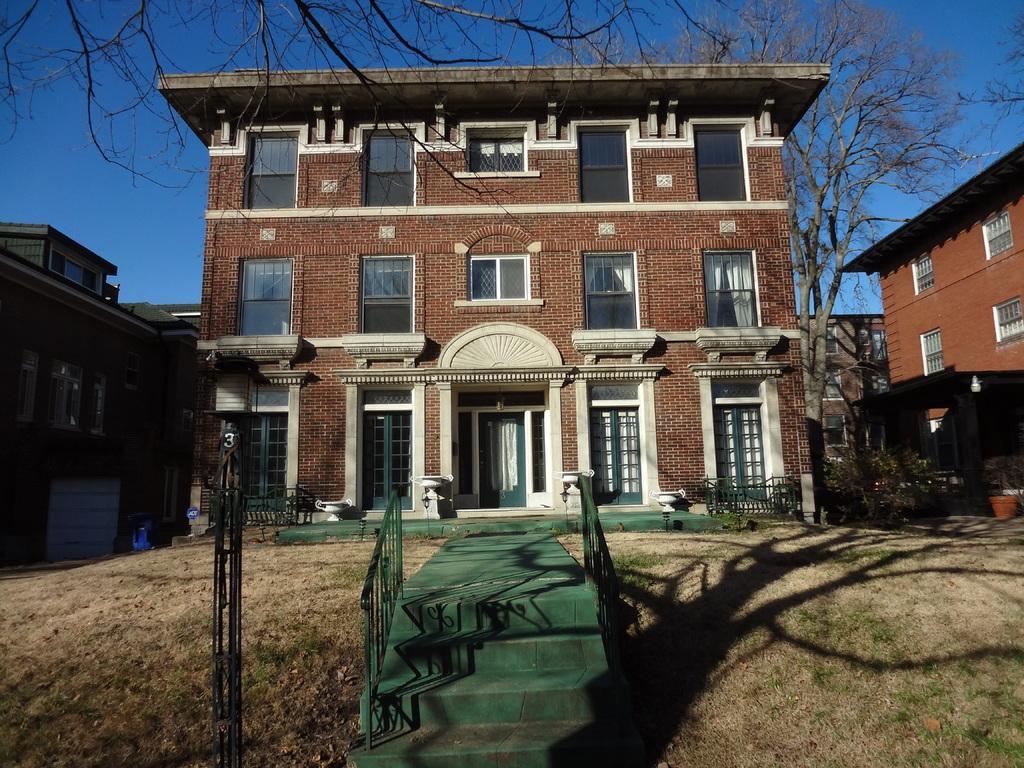Describe this image in one or two sentences. This image consists of the building. It has doors and windows. There are stairs at the bottom. There are trees at the top. There is sky at the top. 